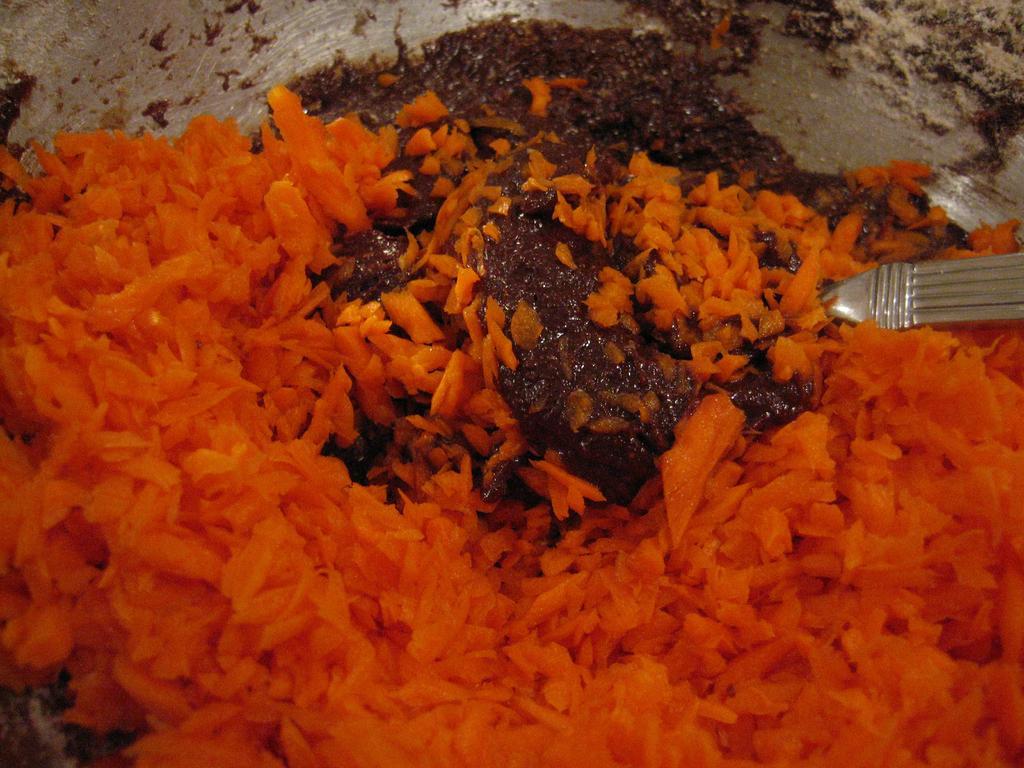In one or two sentences, can you explain what this image depicts? In the image there is some food item being prepared with carrots. 